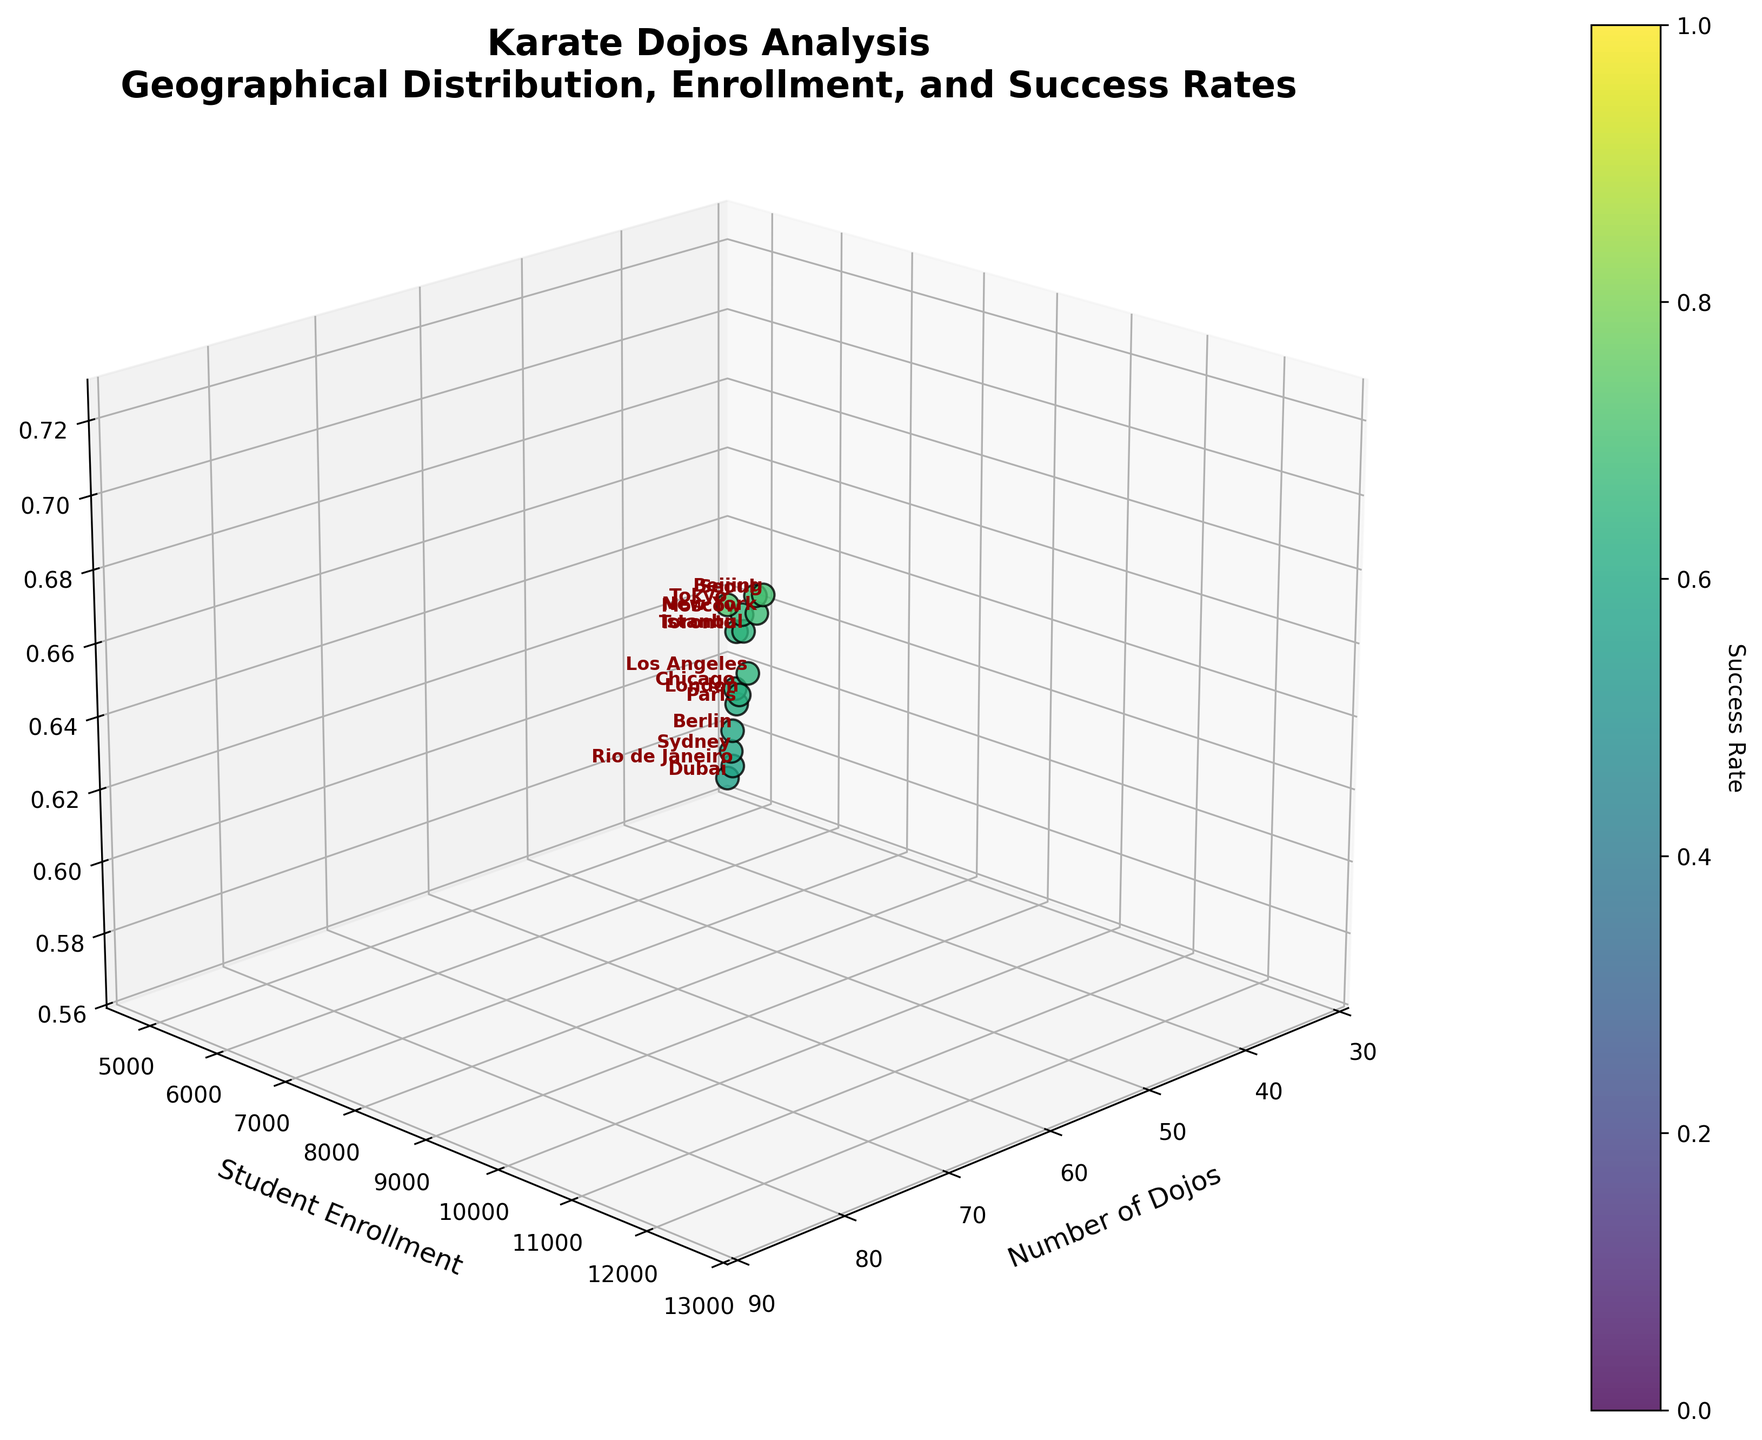Which city has the highest number of dojos? From the plot, identify the data point with the highest value on the x-axis, which represents the number of dojos. The city with the highest number of dojos is Tokyo, with 87 dojos.
Answer: Tokyo Which city has the highest student enrollment? Look at the y-axis values, which represent student enrollment. Identify the data point with the highest y-axis value. The city with the highest student enrollment is Tokyo, with 12,500 students.
Answer: Tokyo What is the success rate for Paris, and how does it compare to Rio de Janeiro? Locate Paris and Rio de Janeiro on the plot and compare their z-values, which represent success rates. Paris has a success rate of 0.61, while Rio de Janeiro has a success rate of 0.58.
Answer: Paris: 0.61, Rio de Janeiro: 0.58 Which city has the lowest success rate, and how many dojos does it have? Identify the data point with the lowest z-axis value, representing the success rate, and look at the corresponding x-axis value for the number of dojos. Dubai has the lowest success rate at 0.57 and has 33 dojos.
Answer: Dubai: 0.57, 33 dojos Comparing student enrollments, which has a higher value: Seoul or Chicago? Locate the data points for Seoul and Chicago on the plot and compare their y-axis values. Seoul has a student enrollment of 10,200, while Chicago has 6,700.
Answer: Seoul How does the number of dojos in London compare to Los Angeles? Find the data points for London and Los Angeles on the plot and compare their x-axis values. London has 51 dojos, and Los Angeles has 58 dojos.
Answer: Los Angeles Which city has a higher success rate: Beijing or Sydney? Locate Beijing and Sydney on the plot and compare their z-axis values. Beijing has a success rate of 0.70, while Sydney has 0.59.
Answer: Beijing What is the average success rate of all the cities in the plot? Calculate the sum of the success rates for all the cities and divide by the number of cities. (0.72 + 0.68 + 0.61 + 0.65 + 0.63 + 0.70 + 0.69 + 0.59 + 0.62 + 0.66 + 0.58 + 0.60 + 0.64 + 0.65 + 0.57) / 15 = 0.64
Answer: 0.64 Which city has the highest success rate, and what are its student enrollment and number of dojos? Identify the data point with the highest z-axis value for the success rate, then check the corresponding x-axis and y-axis values for number of dojos and student enrollment. Tokyo has the highest success rate of 0.72, with 12,500 student enrollments and 87 dojos.
Answer: Tokyo: 12,500 enrollment, 87 dojos Which city is closest to having equal values for number of dojos and student enrollment? Look for a data point where the x-axis (number of dojos) and y-axis (student enrollment) values are closest in magnitude. For rough estimation, none of the cities have closely matching values, but Toronto (47 dojos, 7,000 enrollment) is one notable example of proximity.
Answer: Toronto 